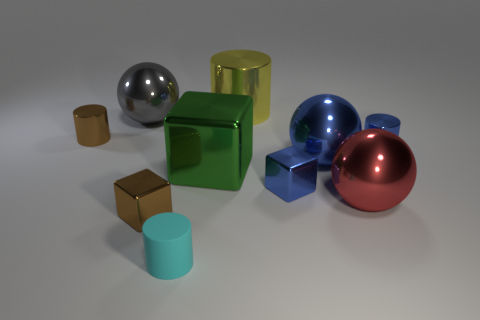There is a red ball that is made of the same material as the big green cube; what is its size?
Your response must be concise. Large. What is the shape of the big gray shiny thing that is behind the brown shiny thing that is behind the blue ball in front of the large shiny cylinder?
Give a very brief answer. Sphere. The cyan cylinder is what size?
Your answer should be very brief. Small. Is there a big red object made of the same material as the blue block?
Your answer should be very brief. Yes. The blue object that is the same shape as the big yellow shiny object is what size?
Offer a terse response. Small. Are there an equal number of cyan things that are behind the big yellow shiny cylinder and big rubber cubes?
Provide a short and direct response. Yes. There is a big object that is behind the big gray metal sphere; is its shape the same as the big blue thing?
Provide a succinct answer. No. There is a tiny matte object; what shape is it?
Your answer should be very brief. Cylinder. There is a brown thing that is in front of the small brown thing left of the brown metal object in front of the tiny blue shiny cylinder; what is its material?
Give a very brief answer. Metal. How many things are tiny rubber cylinders or brown rubber things?
Offer a terse response. 1. 